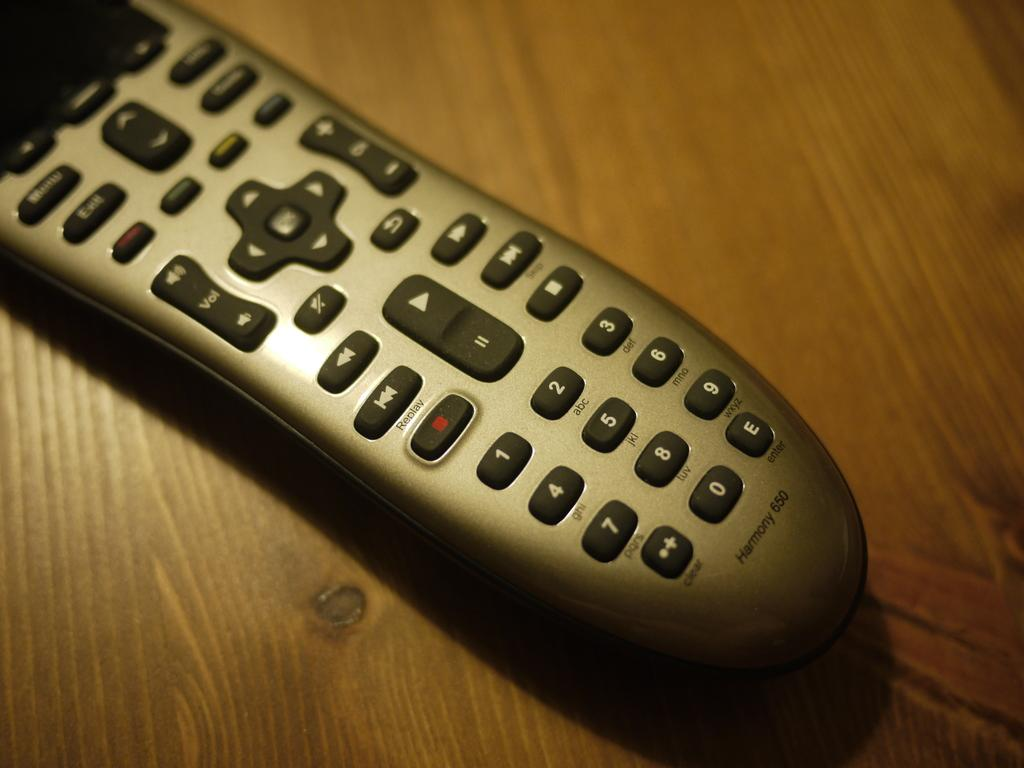<image>
Present a compact description of the photo's key features. A Harmony 650 remote on a wooden table. 